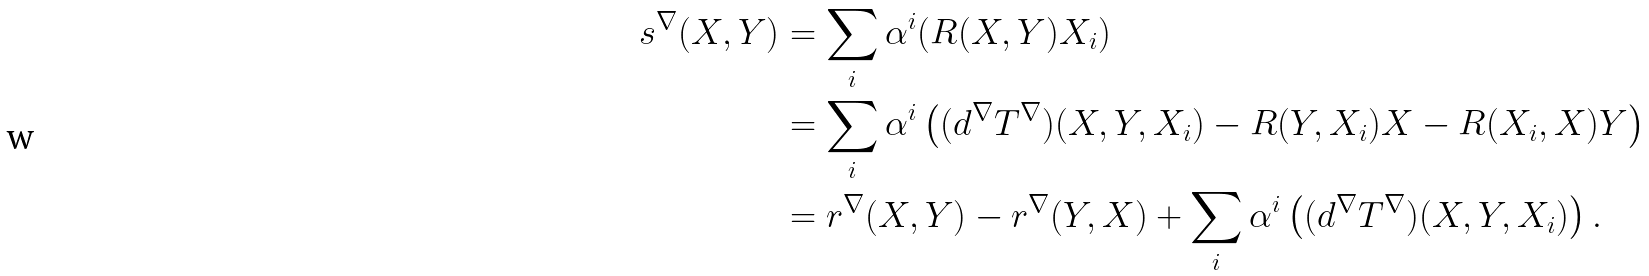Convert formula to latex. <formula><loc_0><loc_0><loc_500><loc_500>s ^ { \nabla } ( X , Y ) & = \sum _ { i } \alpha ^ { i } ( R ( X , Y ) X _ { i } ) \\ & = \sum _ { i } \alpha ^ { i } \left ( ( d ^ { \nabla } T ^ { \nabla } ) ( X , Y , X _ { i } ) - R ( Y , X _ { i } ) X - R ( X _ { i } , X ) Y \right ) \\ & = r ^ { \nabla } ( X , Y ) - r ^ { \nabla } ( Y , X ) + \sum _ { i } \alpha ^ { i } \left ( ( d ^ { \nabla } T ^ { \nabla } ) ( X , Y , X _ { i } ) \right ) .</formula> 